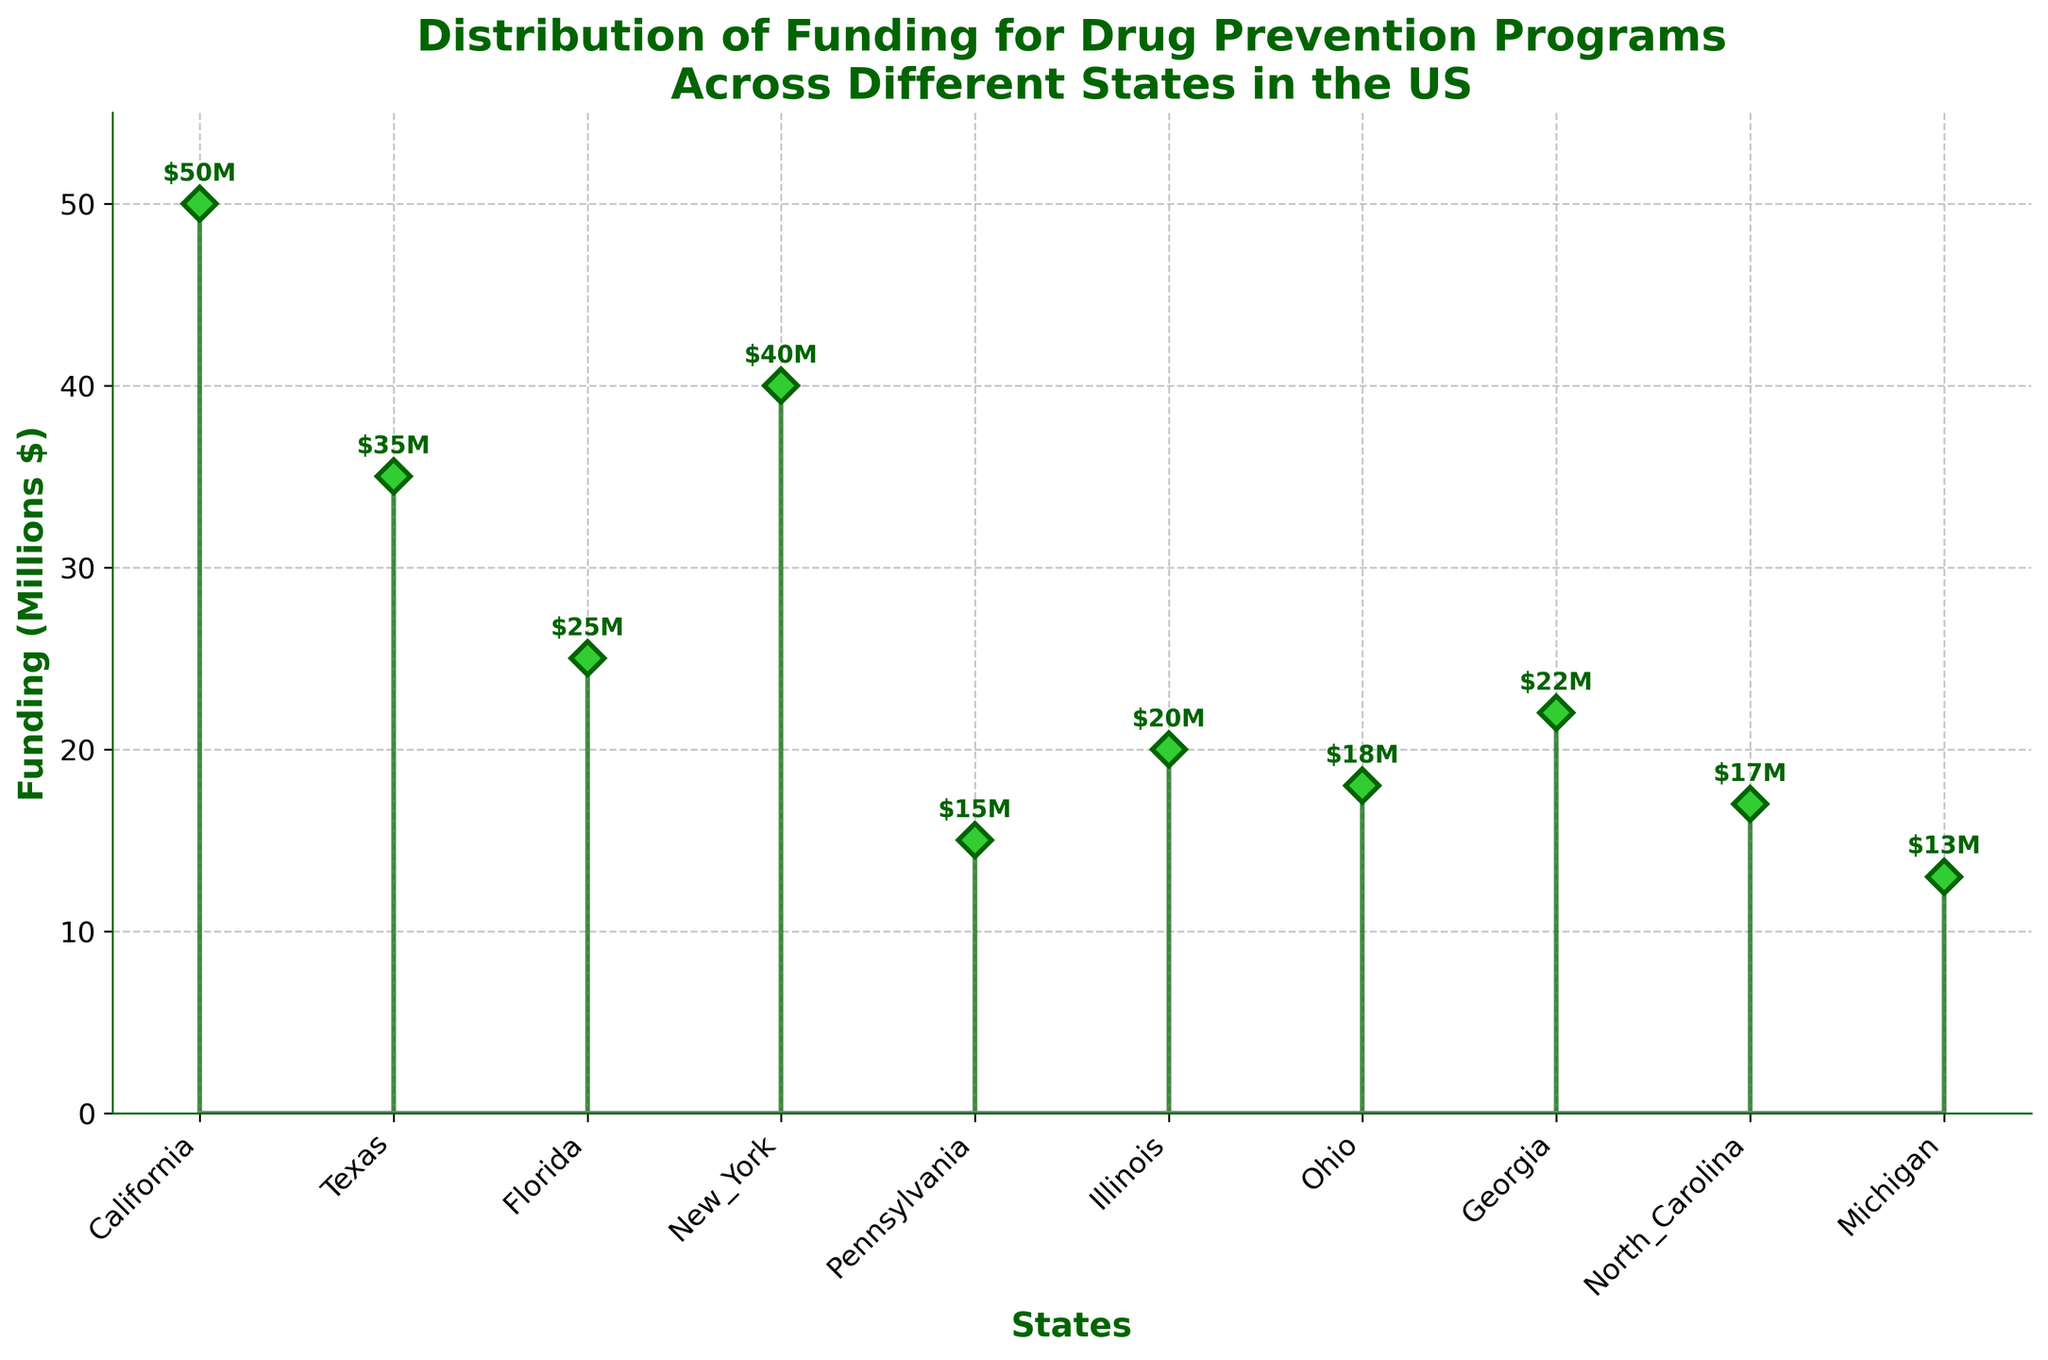What is the title of the figure? The title is located at the top of the figure. It summarizes what the chart is about. The title is "Distribution of Funding for Drug Prevention Programs Across Different States in the US".
Answer: Distribution of Funding for Drug Prevention Programs Across Different States in the US Which state has the highest funding for drug prevention programs? By looking at the peak of the markers in the chart, California has the highest funding, which is represented as $50M.
Answer: California How much funding is allocated for drug prevention programs in New York? Locate the marker corresponding to New York on the x-axis and check the value associated with it. New York has $40M in funding.
Answer: $40M What's the difference in funding between the highest and lowest funded states? The highest funding is $50M (California) and the lowest is $13M (Michigan). The difference is calculated by subtracting the two values. 50 - 13 = 37.
Answer: $37M Which two states have the closest funding amounts and what are those amounts? By observing the proximity of the markers, Georgia ($22M) and Illinois ($20M) have the closest funding amounts, with a difference of $2M.
Answer: Georgia and Illinois ($22M and $20M) What is the total funding for the states listed in the figure? Sum all the funding amounts from each state: 50+35+25+40+15+20+18+22+17+13 = 255.
Answer: $255M What is the average funding amount across all the states? The total funding is $255M and there are 10 states. Average is calculated as 255/10 = 25.5.
Answer: $25.5M Does Ohio have more or less funding compared to Texas? How much more or less? Ohio has $18M and Texas has $35M. Ohio has $17M less than Texas. 35 - 18 = 17.
Answer: Less by $17M How many states have funding amounts greater than $20M? Identify and count all markers that have values greater than $20M. They are California, Texas, Florida, New York, and Georgia, so 5 states.
Answer: 5 What is the range of funding values in the figure? The range is calculated by subtracting the smallest amount from the largest. The highest value is $50M (California) and the lowest is $13M (Michigan). Range = 50 - 13 = 37.
Answer: $37M 